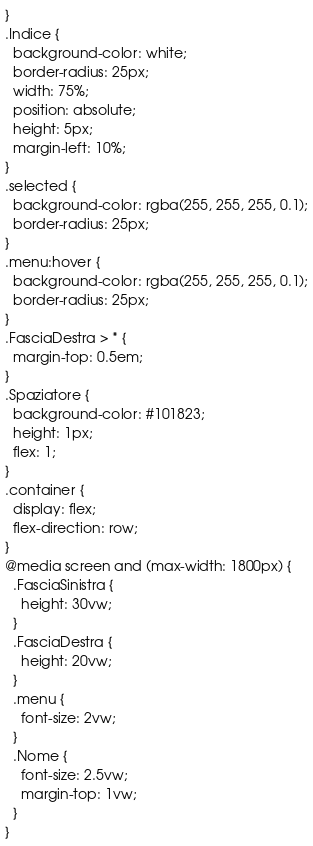Convert code to text. <code><loc_0><loc_0><loc_500><loc_500><_CSS_>}
.Indice {
  background-color: white;
  border-radius: 25px;
  width: 75%;
  position: absolute;
  height: 5px;
  margin-left: 10%;
}
.selected {
  background-color: rgba(255, 255, 255, 0.1);
  border-radius: 25px;
}
.menu:hover {
  background-color: rgba(255, 255, 255, 0.1);
  border-radius: 25px;
}
.FasciaDestra > * {
  margin-top: 0.5em;
}
.Spaziatore {
  background-color: #101823;
  height: 1px;
  flex: 1;
}
.container {
  display: flex;
  flex-direction: row;
}
@media screen and (max-width: 1800px) {
  .FasciaSinistra {
    height: 30vw;
  }
  .FasciaDestra {
    height: 20vw;
  }
  .menu {
    font-size: 2vw;
  }
  .Nome {
    font-size: 2.5vw;
    margin-top: 1vw;
  }
}
</code> 